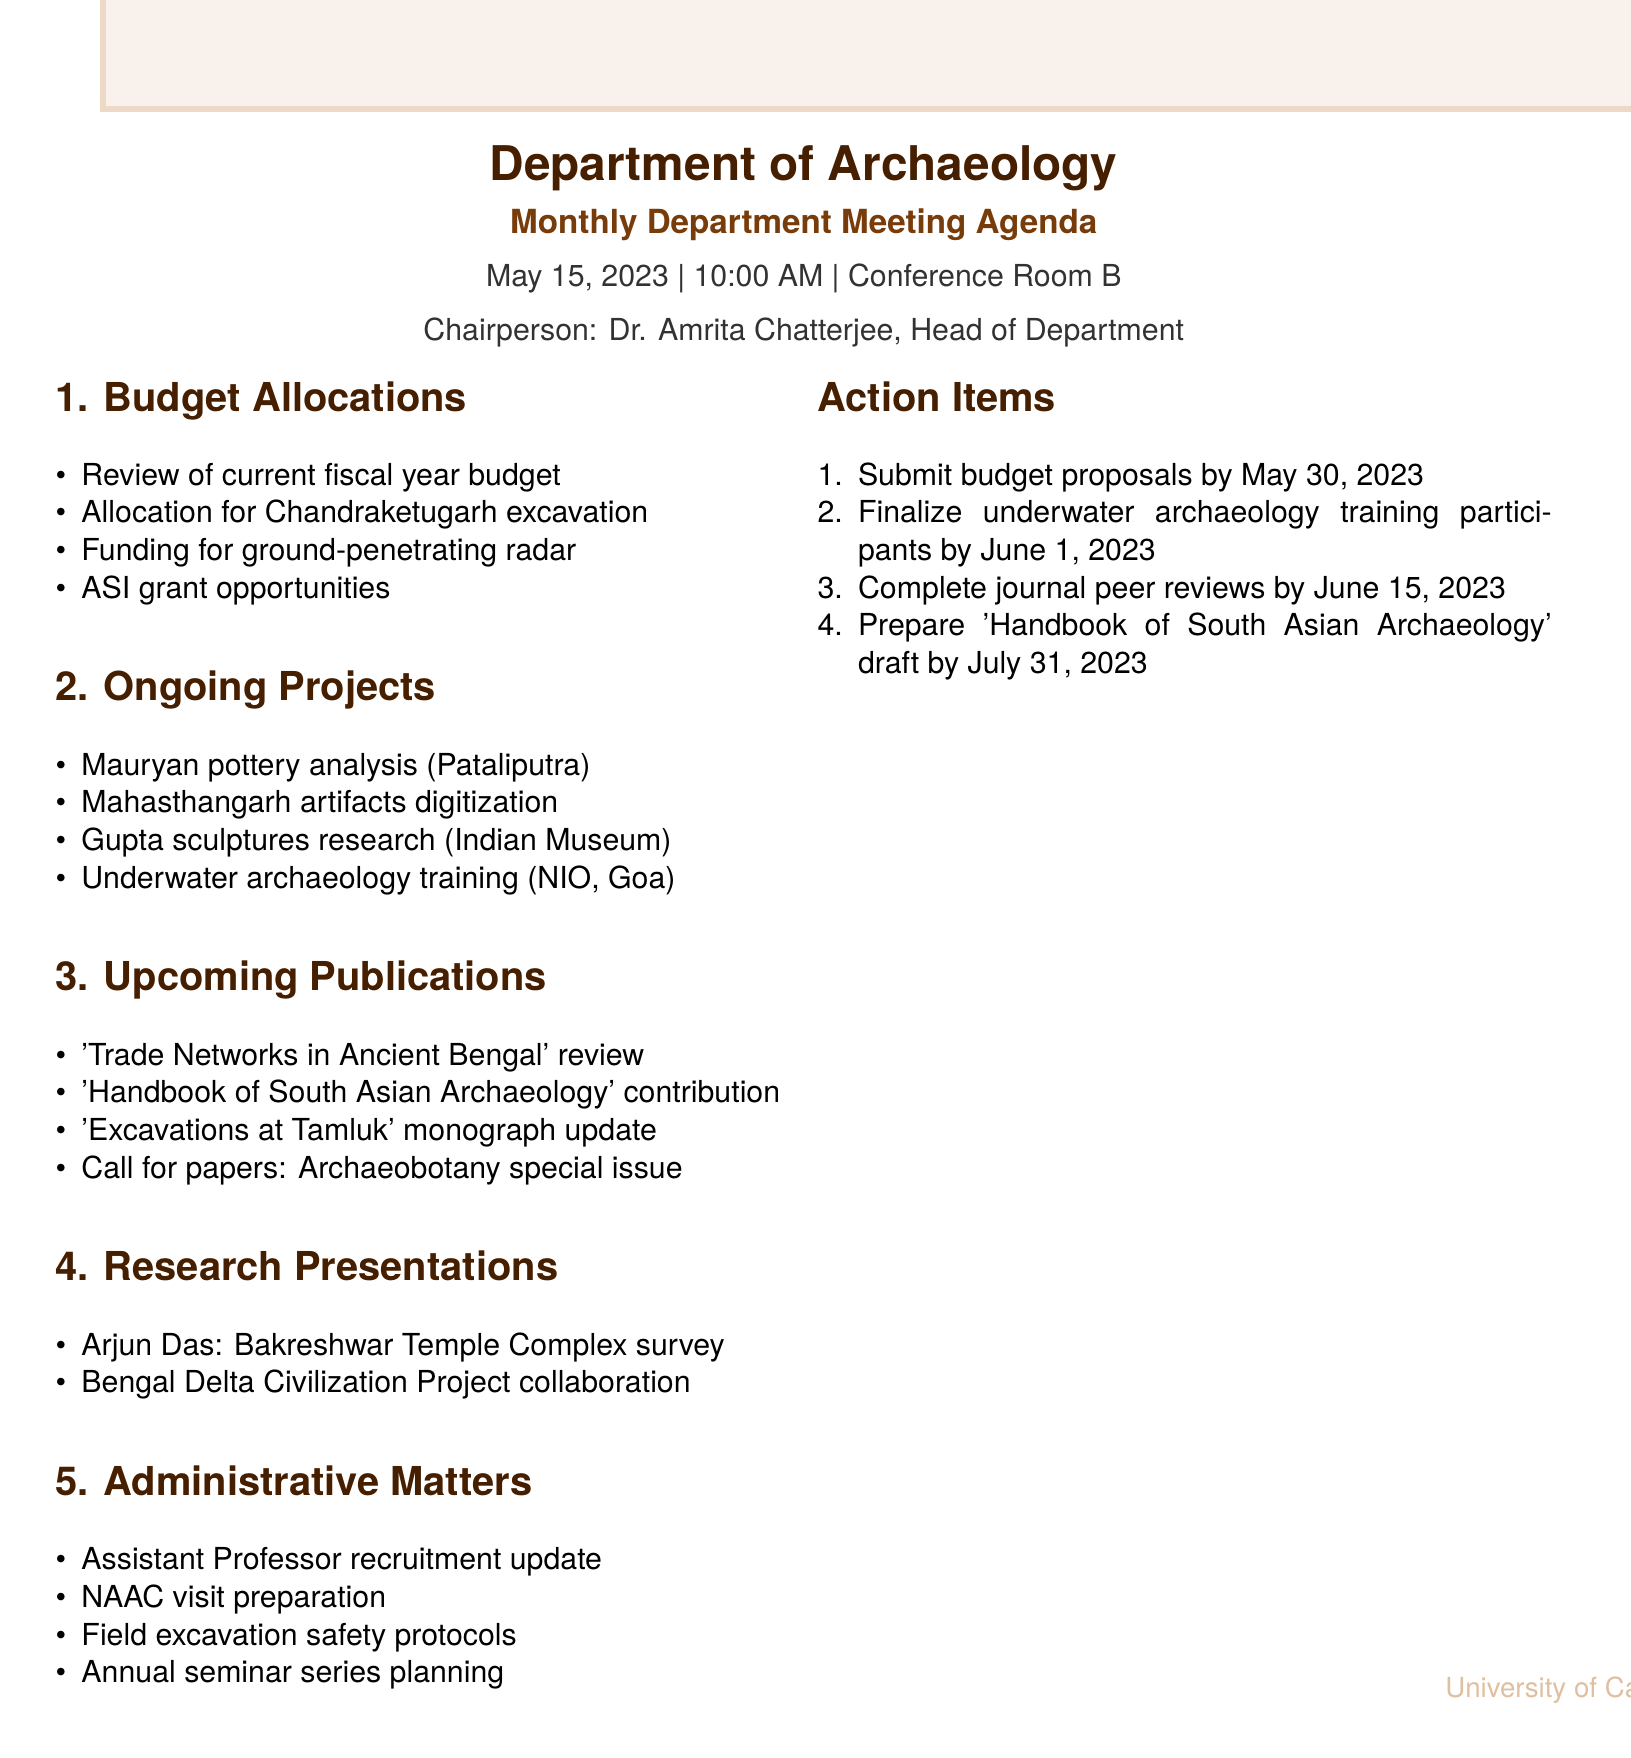What is the date of the meeting? The date of the meeting is mentioned in the document as May 15, 2023.
Answer: May 15, 2023 Who is the chairperson of the meeting? The chairperson is identified as Dr. Amrita Chatterjee in the document.
Answer: Dr. Amrita Chatterjee What is one of the topics listed under Budget Allocations? One of the topics included in the Budget Allocations section is mentioned as "Funding request for new ground-penetrating radar equipment."
Answer: Funding request for new ground-penetrating radar equipment How many action items are listed in the document? The document states there are four action items listed.
Answer: 4 What is the title of Dr. Rajesh Mukherjee's paper under Upcoming Publications? The title of the paper is 'Trade Networks in Ancient Bengal' as specified in the document.
Answer: Trade Networks in Ancient Bengal Which program is mentioned in the Ongoing Projects section? The document lists "underwater archaeology training program with National Institute of Oceanography, Goa" as an ongoing project.
Answer: underwater archaeology training program with National Institute of Oceanography, Goa What is the deadline for submitting budget proposals? The deadline for submitting budget proposals is indicated as May 30, 2023, in the action items.
Answer: May 30, 2023 Which researcher will present during the meeting? The document mentions junior researcher Arjun Das will present on "Preliminary findings from the Bakreshwar Temple Complex survey."
Answer: Arjun Das What document is the department contributing to under Upcoming Publications? The document specifies that the department's contribution is to the "Handbook of South Asian Archaeology."
Answer: Handbook of South Asian Archaeology 